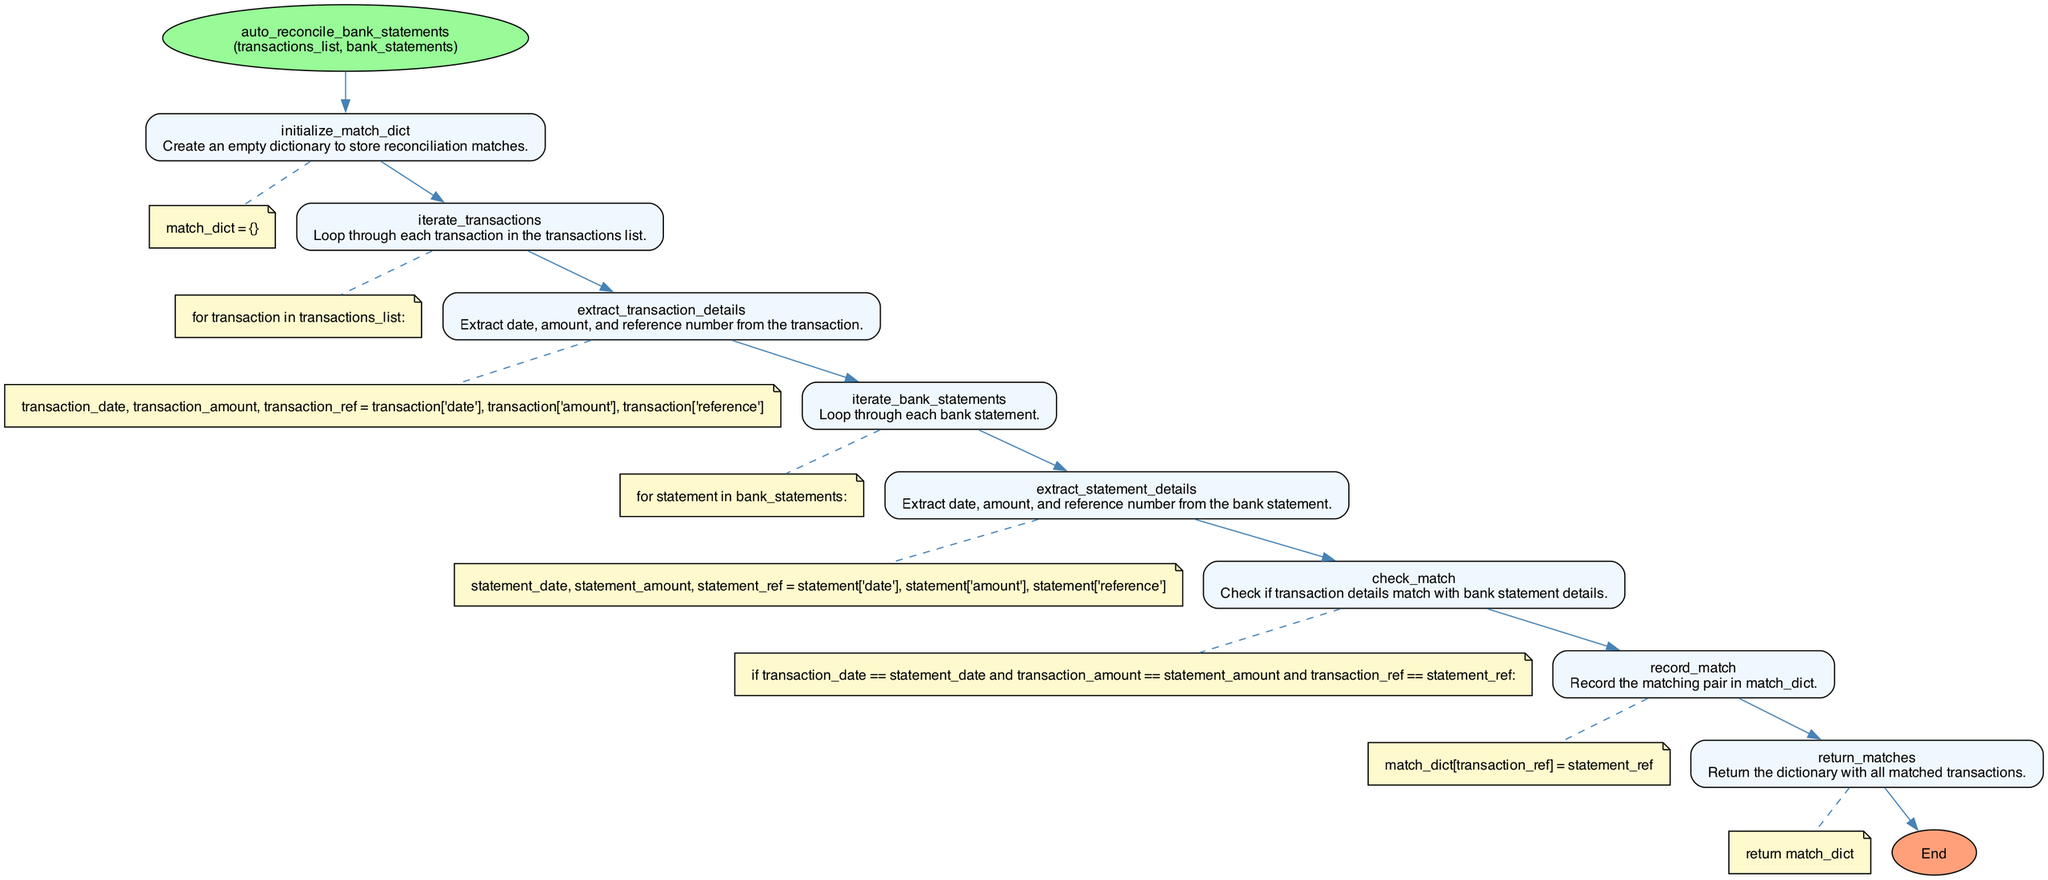what is the name of the function depicted in the diagram? The diagram represents a function with the name "auto_reconcile_bank_statements" which is mentioned at the start of the flowchart.
Answer: auto_reconcile_bank_statements how many parameters does the function accept? The diagram specifies that the function takes two parameters: "transactions_list" and "bank_statements," as indicated next to the function name.
Answer: 2 what is the first step in the process described by the flowchart? The first step in the flowchart, connected directly to the start node, is to "initialize_match_dict." This describes the creation of an empty dictionary to store matches.
Answer: initialize_match_dict what does the block "check_match" do? The block labeled "check_match" checks whether the details extracted from a transaction match those from a bank statement based on date, amount, and reference number.
Answer: checks transaction details how many nodes are present in the flowchart? The diagram shows a total of nine nodes, including the start and end nodes, along with the various processing steps in between.
Answer: 9 what information is recorded in the "record_match" step? In the "record_match" step, a matching pair of transaction reference and statement reference is saved in the dictionary called match_dict.
Answer: saves matching pairs what happens after the "iterate_transactions" step? After the "iterate_transactions" step, the flowchart proceeds to the "iterate_bank_statements" step, indicating a nested loop structure where each transaction is matched with bank statements.
Answer: iterate_bank_statements what is the final step of the flowchart? The final step of the flowchart is "return_matches," which indicates that the matching results will be returned to the caller.
Answer: return_matches which two elements involve extracting details and what do they extract? The two elements that involve extracting details are "extract_transaction_details" and "extract_statement_details." They extract date, amount, and reference number from transactions and bank statements, respectively.
Answer: extract_transaction_details, extract_statement_details 